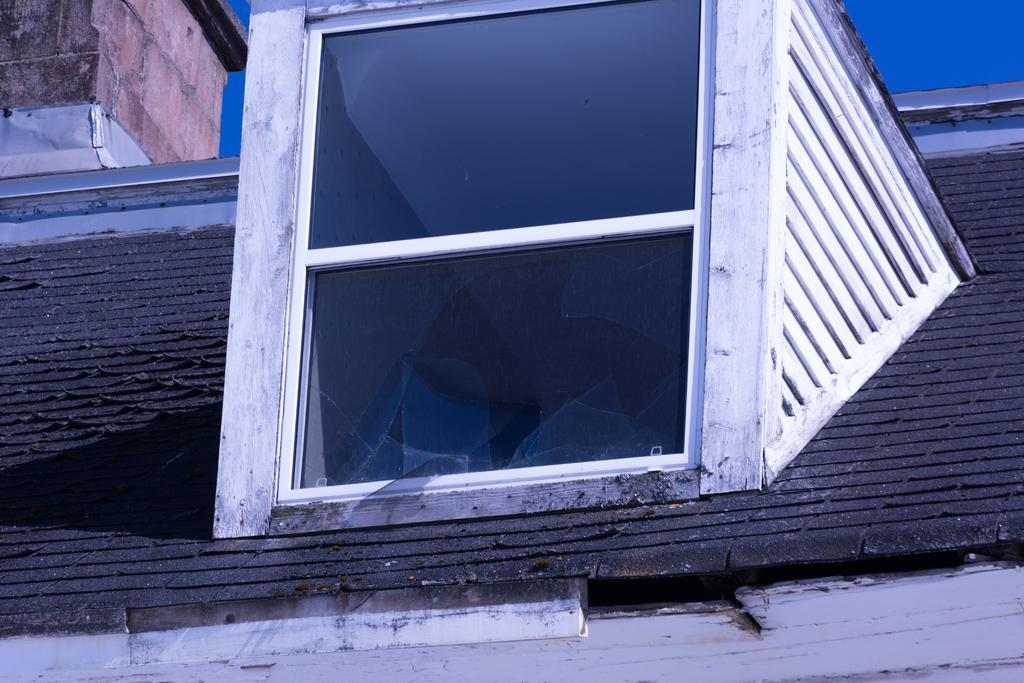In one or two sentences, can you explain what this image depicts? In this image there is a shed and we can see a window. In the background there is sky. 